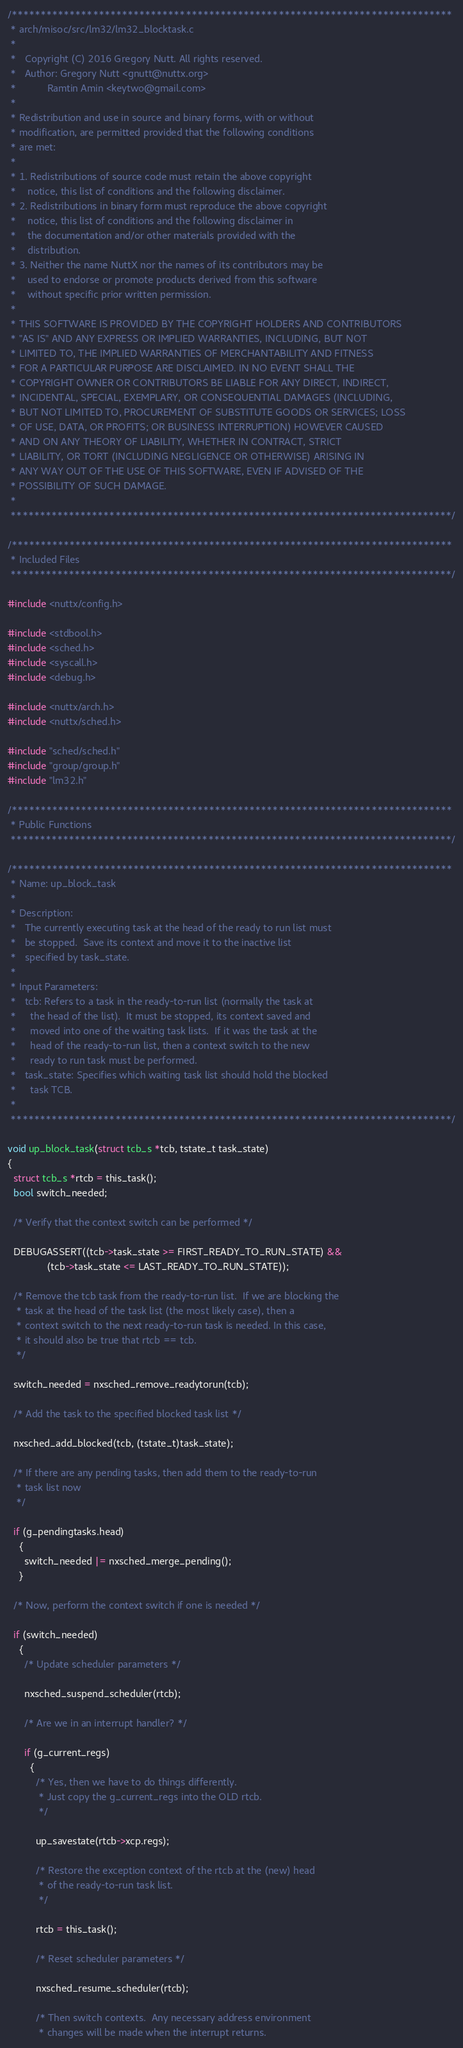Convert code to text. <code><loc_0><loc_0><loc_500><loc_500><_C_>/****************************************************************************
 * arch/misoc/src/lm32/lm32_blocktask.c
 *
 *   Copyright (C) 2016 Gregory Nutt. All rights reserved.
 *   Author: Gregory Nutt <gnutt@nuttx.org>
 *           Ramtin Amin <keytwo@gmail.com>
 *
 * Redistribution and use in source and binary forms, with or without
 * modification, are permitted provided that the following conditions
 * are met:
 *
 * 1. Redistributions of source code must retain the above copyright
 *    notice, this list of conditions and the following disclaimer.
 * 2. Redistributions in binary form must reproduce the above copyright
 *    notice, this list of conditions and the following disclaimer in
 *    the documentation and/or other materials provided with the
 *    distribution.
 * 3. Neither the name NuttX nor the names of its contributors may be
 *    used to endorse or promote products derived from this software
 *    without specific prior written permission.
 *
 * THIS SOFTWARE IS PROVIDED BY THE COPYRIGHT HOLDERS AND CONTRIBUTORS
 * "AS IS" AND ANY EXPRESS OR IMPLIED WARRANTIES, INCLUDING, BUT NOT
 * LIMITED TO, THE IMPLIED WARRANTIES OF MERCHANTABILITY AND FITNESS
 * FOR A PARTICULAR PURPOSE ARE DISCLAIMED. IN NO EVENT SHALL THE
 * COPYRIGHT OWNER OR CONTRIBUTORS BE LIABLE FOR ANY DIRECT, INDIRECT,
 * INCIDENTAL, SPECIAL, EXEMPLARY, OR CONSEQUENTIAL DAMAGES (INCLUDING,
 * BUT NOT LIMITED TO, PROCUREMENT OF SUBSTITUTE GOODS OR SERVICES; LOSS
 * OF USE, DATA, OR PROFITS; OR BUSINESS INTERRUPTION) HOWEVER CAUSED
 * AND ON ANY THEORY OF LIABILITY, WHETHER IN CONTRACT, STRICT
 * LIABILITY, OR TORT (INCLUDING NEGLIGENCE OR OTHERWISE) ARISING IN
 * ANY WAY OUT OF THE USE OF THIS SOFTWARE, EVEN IF ADVISED OF THE
 * POSSIBILITY OF SUCH DAMAGE.
 *
 ****************************************************************************/

/****************************************************************************
 * Included Files
 ****************************************************************************/

#include <nuttx/config.h>

#include <stdbool.h>
#include <sched.h>
#include <syscall.h>
#include <debug.h>

#include <nuttx/arch.h>
#include <nuttx/sched.h>

#include "sched/sched.h"
#include "group/group.h"
#include "lm32.h"

/****************************************************************************
 * Public Functions
 ****************************************************************************/

/****************************************************************************
 * Name: up_block_task
 *
 * Description:
 *   The currently executing task at the head of the ready to run list must
 *   be stopped.  Save its context and move it to the inactive list
 *   specified by task_state.
 *
 * Input Parameters:
 *   tcb: Refers to a task in the ready-to-run list (normally the task at
 *     the head of the list).  It must be stopped, its context saved and
 *     moved into one of the waiting task lists.  If it was the task at the
 *     head of the ready-to-run list, then a context switch to the new
 *     ready to run task must be performed.
 *   task_state: Specifies which waiting task list should hold the blocked
 *     task TCB.
 *
 ****************************************************************************/

void up_block_task(struct tcb_s *tcb, tstate_t task_state)
{
  struct tcb_s *rtcb = this_task();
  bool switch_needed;

  /* Verify that the context switch can be performed */

  DEBUGASSERT((tcb->task_state >= FIRST_READY_TO_RUN_STATE) &&
              (tcb->task_state <= LAST_READY_TO_RUN_STATE));

  /* Remove the tcb task from the ready-to-run list.  If we are blocking the
   * task at the head of the task list (the most likely case), then a
   * context switch to the next ready-to-run task is needed. In this case,
   * it should also be true that rtcb == tcb.
   */

  switch_needed = nxsched_remove_readytorun(tcb);

  /* Add the task to the specified blocked task list */

  nxsched_add_blocked(tcb, (tstate_t)task_state);

  /* If there are any pending tasks, then add them to the ready-to-run
   * task list now
   */

  if (g_pendingtasks.head)
    {
      switch_needed |= nxsched_merge_pending();
    }

  /* Now, perform the context switch if one is needed */

  if (switch_needed)
    {
      /* Update scheduler parameters */

      nxsched_suspend_scheduler(rtcb);

      /* Are we in an interrupt handler? */

      if (g_current_regs)
        {
          /* Yes, then we have to do things differently.
           * Just copy the g_current_regs into the OLD rtcb.
           */

          up_savestate(rtcb->xcp.regs);

          /* Restore the exception context of the rtcb at the (new) head
           * of the ready-to-run task list.
           */

          rtcb = this_task();

          /* Reset scheduler parameters */

          nxsched_resume_scheduler(rtcb);

          /* Then switch contexts.  Any necessary address environment
           * changes will be made when the interrupt returns.</code> 